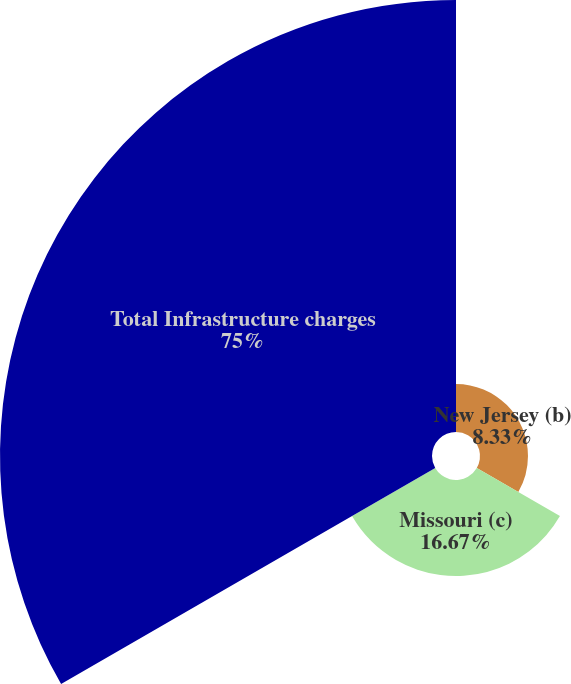Convert chart to OTSL. <chart><loc_0><loc_0><loc_500><loc_500><pie_chart><fcel>New Jersey (b)<fcel>Missouri (c)<fcel>Total Infrastructure charges<nl><fcel>8.33%<fcel>16.67%<fcel>75.0%<nl></chart> 